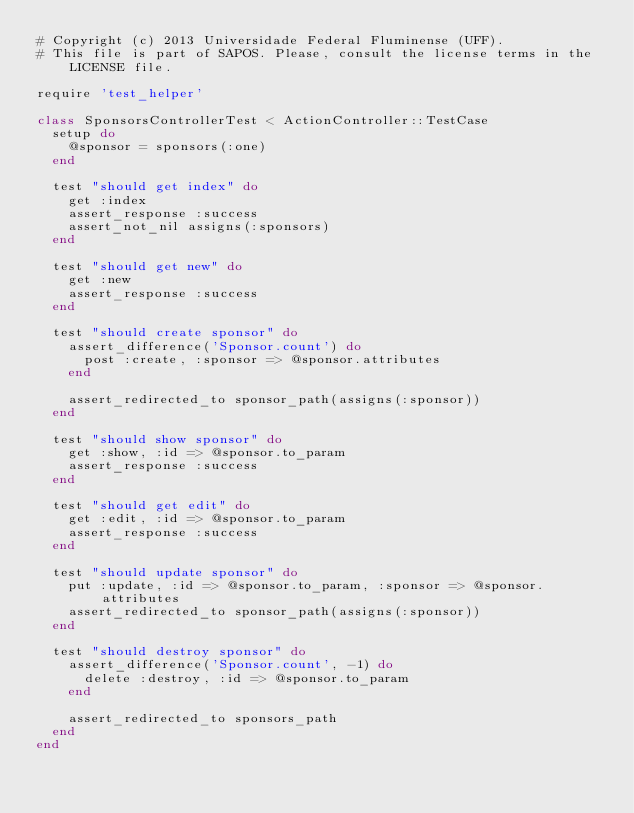Convert code to text. <code><loc_0><loc_0><loc_500><loc_500><_Ruby_># Copyright (c) 2013 Universidade Federal Fluminense (UFF).
# This file is part of SAPOS. Please, consult the license terms in the LICENSE file.

require 'test_helper'

class SponsorsControllerTest < ActionController::TestCase
  setup do
    @sponsor = sponsors(:one)
  end

  test "should get index" do
    get :index
    assert_response :success
    assert_not_nil assigns(:sponsors)
  end

  test "should get new" do
    get :new
    assert_response :success
  end

  test "should create sponsor" do
    assert_difference('Sponsor.count') do
      post :create, :sponsor => @sponsor.attributes
    end

    assert_redirected_to sponsor_path(assigns(:sponsor))
  end

  test "should show sponsor" do
    get :show, :id => @sponsor.to_param
    assert_response :success
  end

  test "should get edit" do
    get :edit, :id => @sponsor.to_param
    assert_response :success
  end

  test "should update sponsor" do
    put :update, :id => @sponsor.to_param, :sponsor => @sponsor.attributes
    assert_redirected_to sponsor_path(assigns(:sponsor))
  end

  test "should destroy sponsor" do
    assert_difference('Sponsor.count', -1) do
      delete :destroy, :id => @sponsor.to_param
    end

    assert_redirected_to sponsors_path
  end
end
</code> 